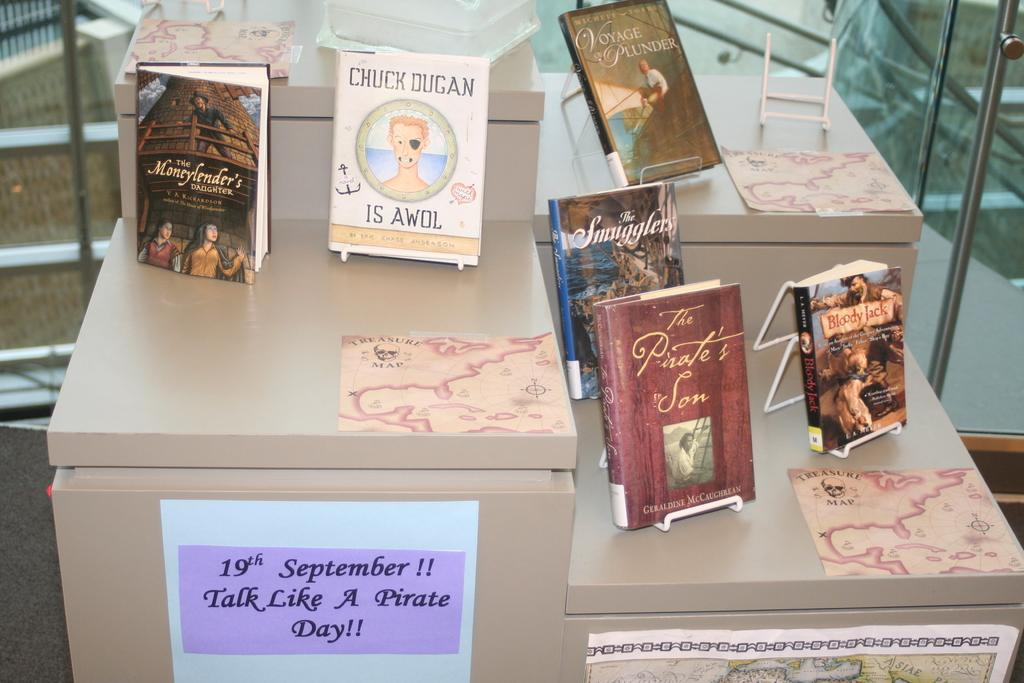<image>
Create a compact narrative representing the image presented. A collection of books on a shelf with one of them being Chuck dugan is awol. 